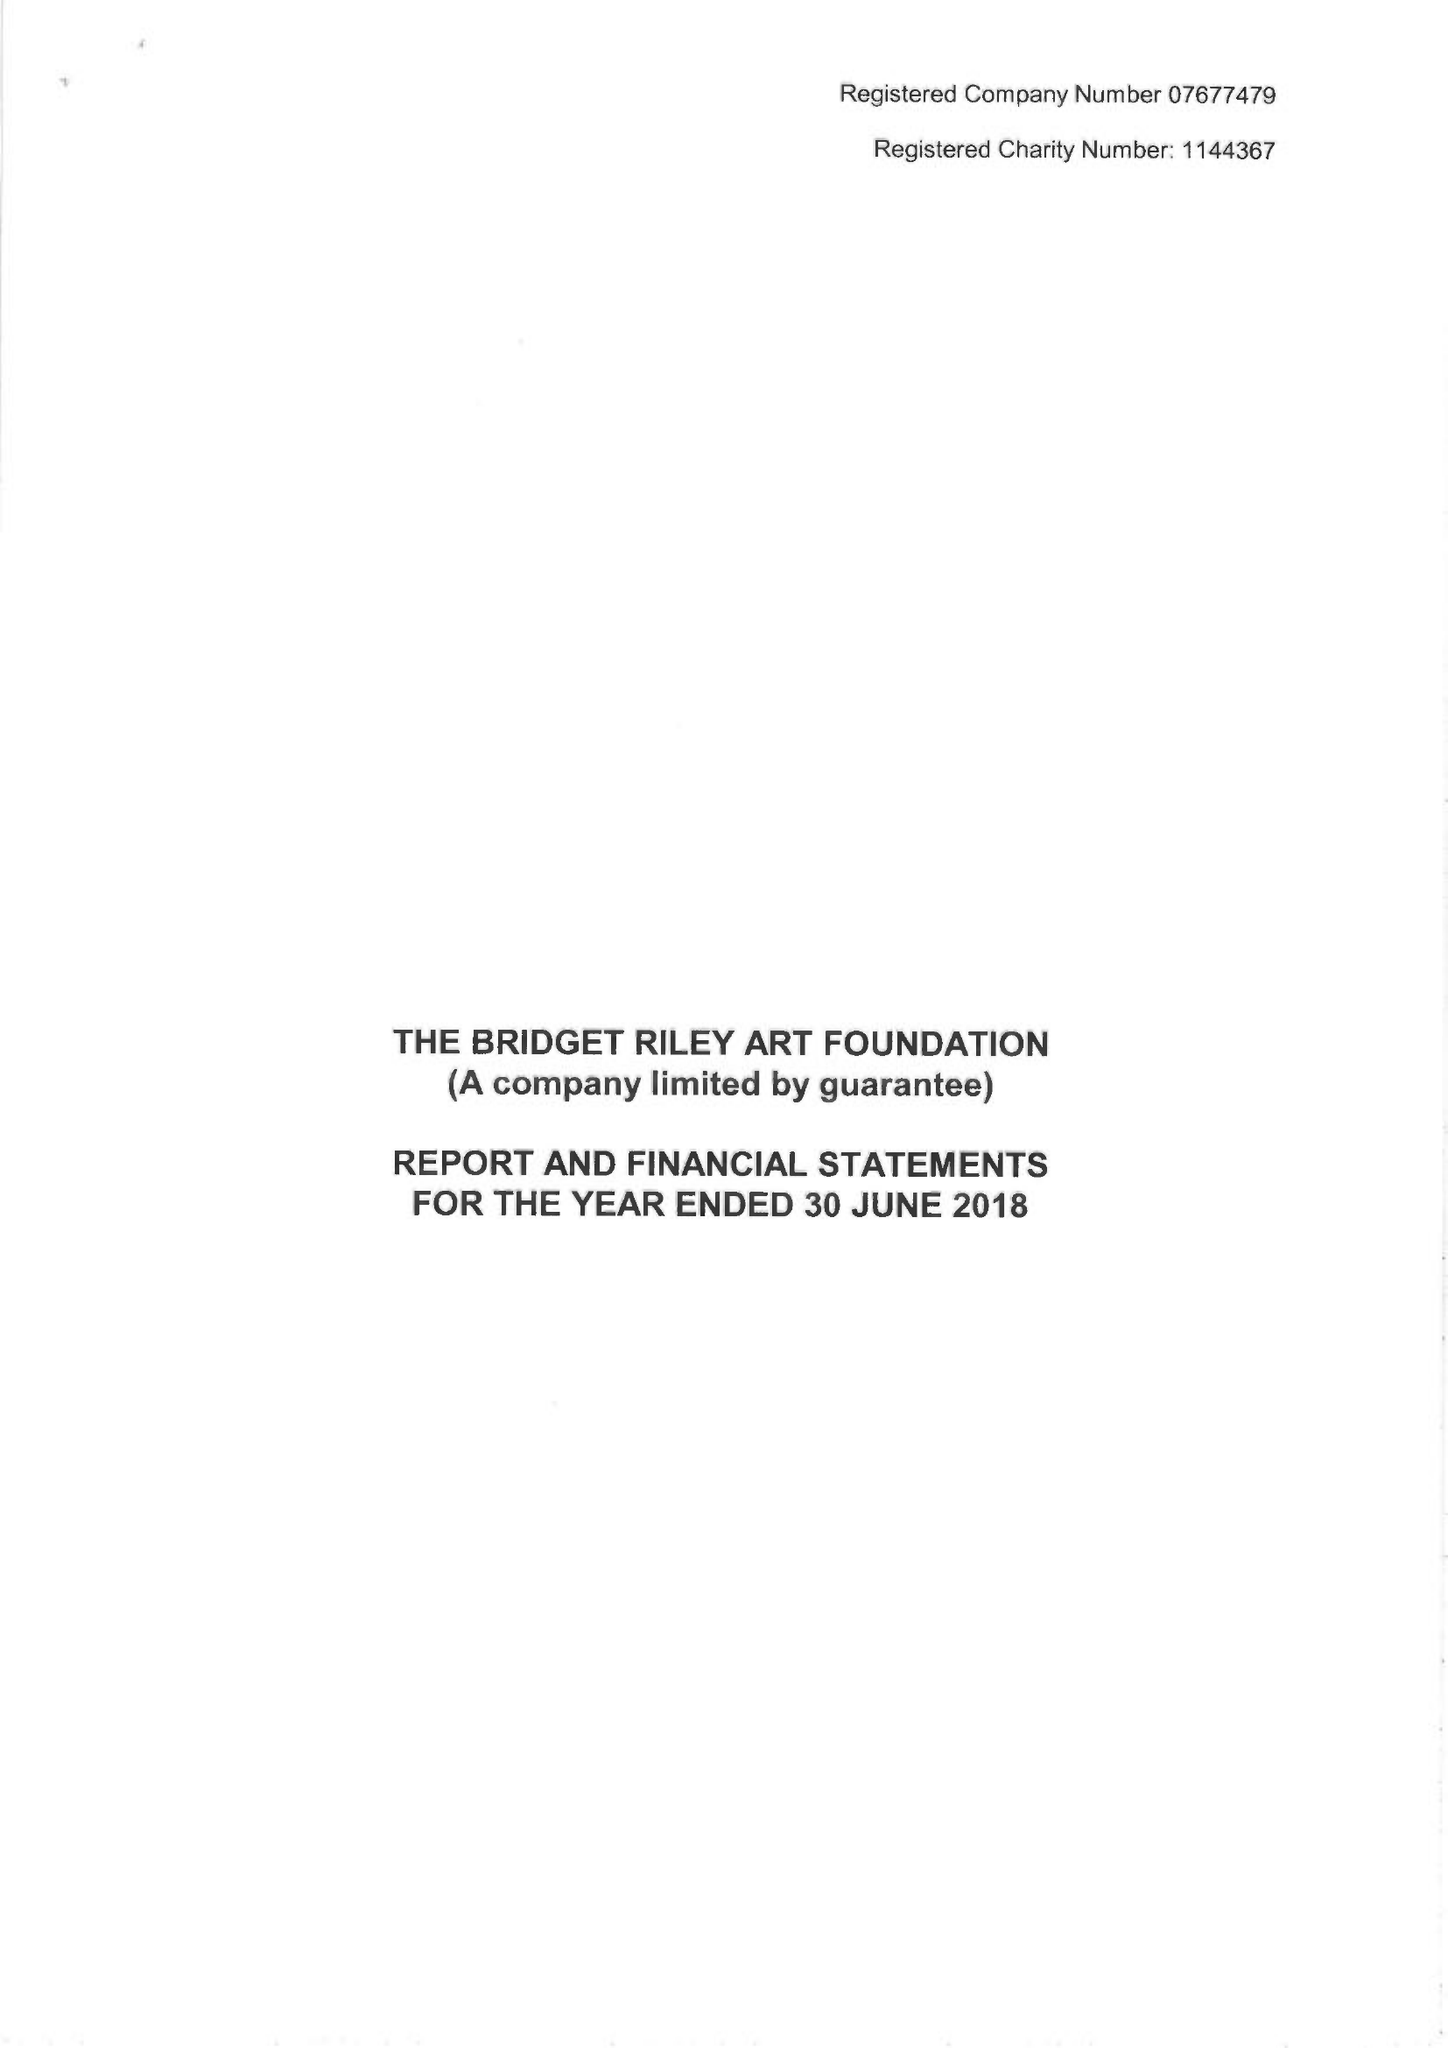What is the value for the income_annually_in_british_pounds?
Answer the question using a single word or phrase. 448925.00 